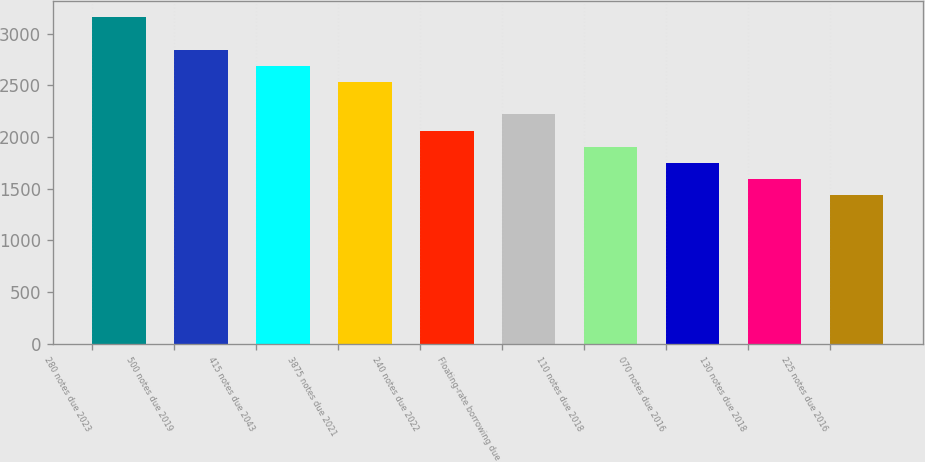Convert chart. <chart><loc_0><loc_0><loc_500><loc_500><bar_chart><fcel>280 notes due 2023<fcel>500 notes due 2019<fcel>415 notes due 2043<fcel>3875 notes due 2021<fcel>240 notes due 2022<fcel>Floating-rate borrowing due<fcel>110 notes due 2018<fcel>070 notes due 2016<fcel>130 notes due 2018<fcel>225 notes due 2016<nl><fcel>3155.7<fcel>2843.1<fcel>2686.8<fcel>2530.5<fcel>2061.6<fcel>2217.9<fcel>1905.3<fcel>1749<fcel>1592.7<fcel>1436.4<nl></chart> 